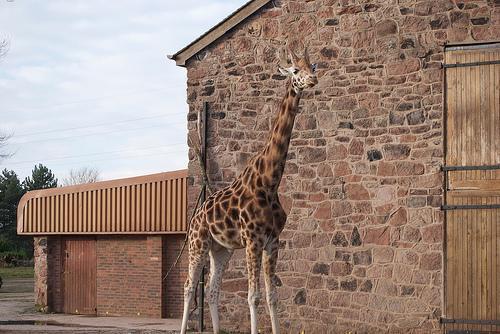How many doors?
Give a very brief answer. 2. 